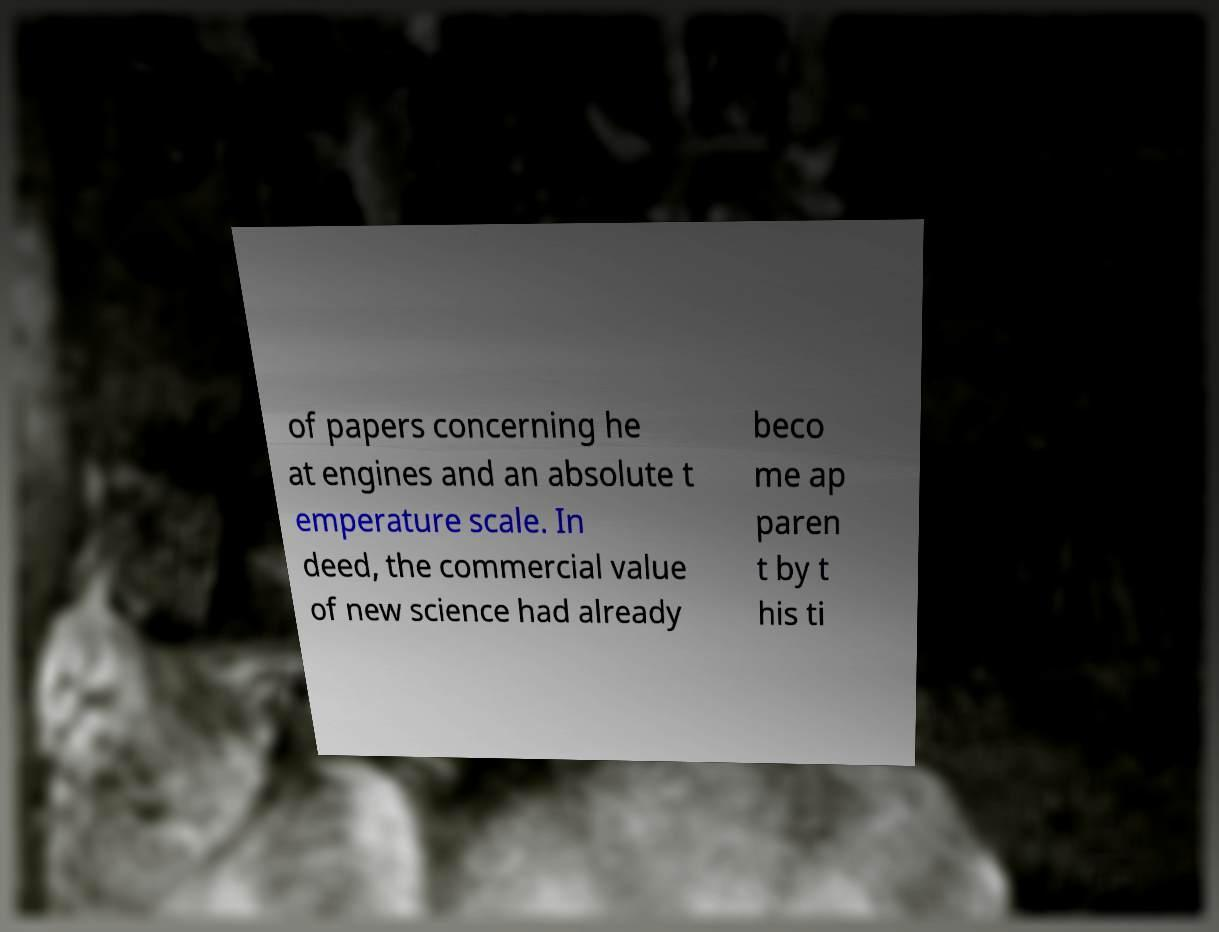I need the written content from this picture converted into text. Can you do that? of papers concerning he at engines and an absolute t emperature scale. In deed, the commercial value of new science had already beco me ap paren t by t his ti 